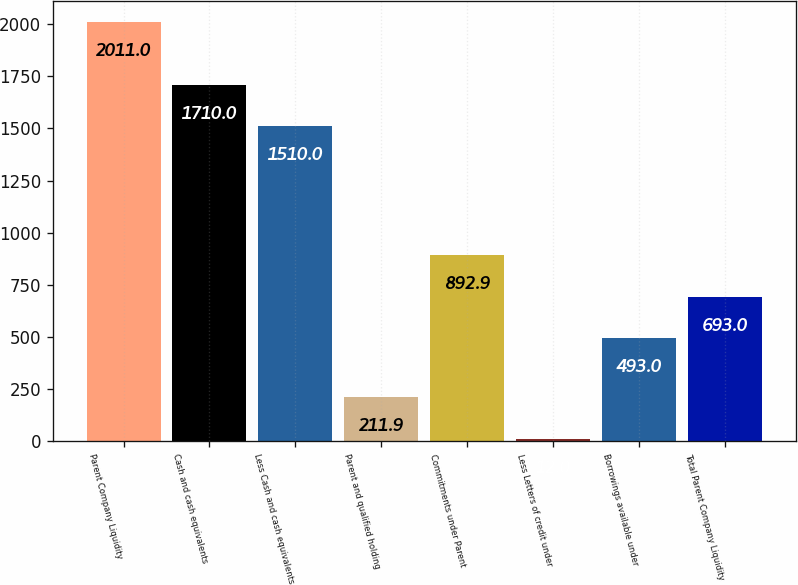Convert chart to OTSL. <chart><loc_0><loc_0><loc_500><loc_500><bar_chart><fcel>Parent Company Liquidity<fcel>Cash and cash equivalents<fcel>Less Cash and cash equivalents<fcel>Parent and qualified holding<fcel>Commitments under Parent<fcel>Less Letters of credit under<fcel>Borrowings available under<fcel>Total Parent Company Liquidity<nl><fcel>2011<fcel>1710<fcel>1510<fcel>211.9<fcel>892.9<fcel>12<fcel>493<fcel>693<nl></chart> 